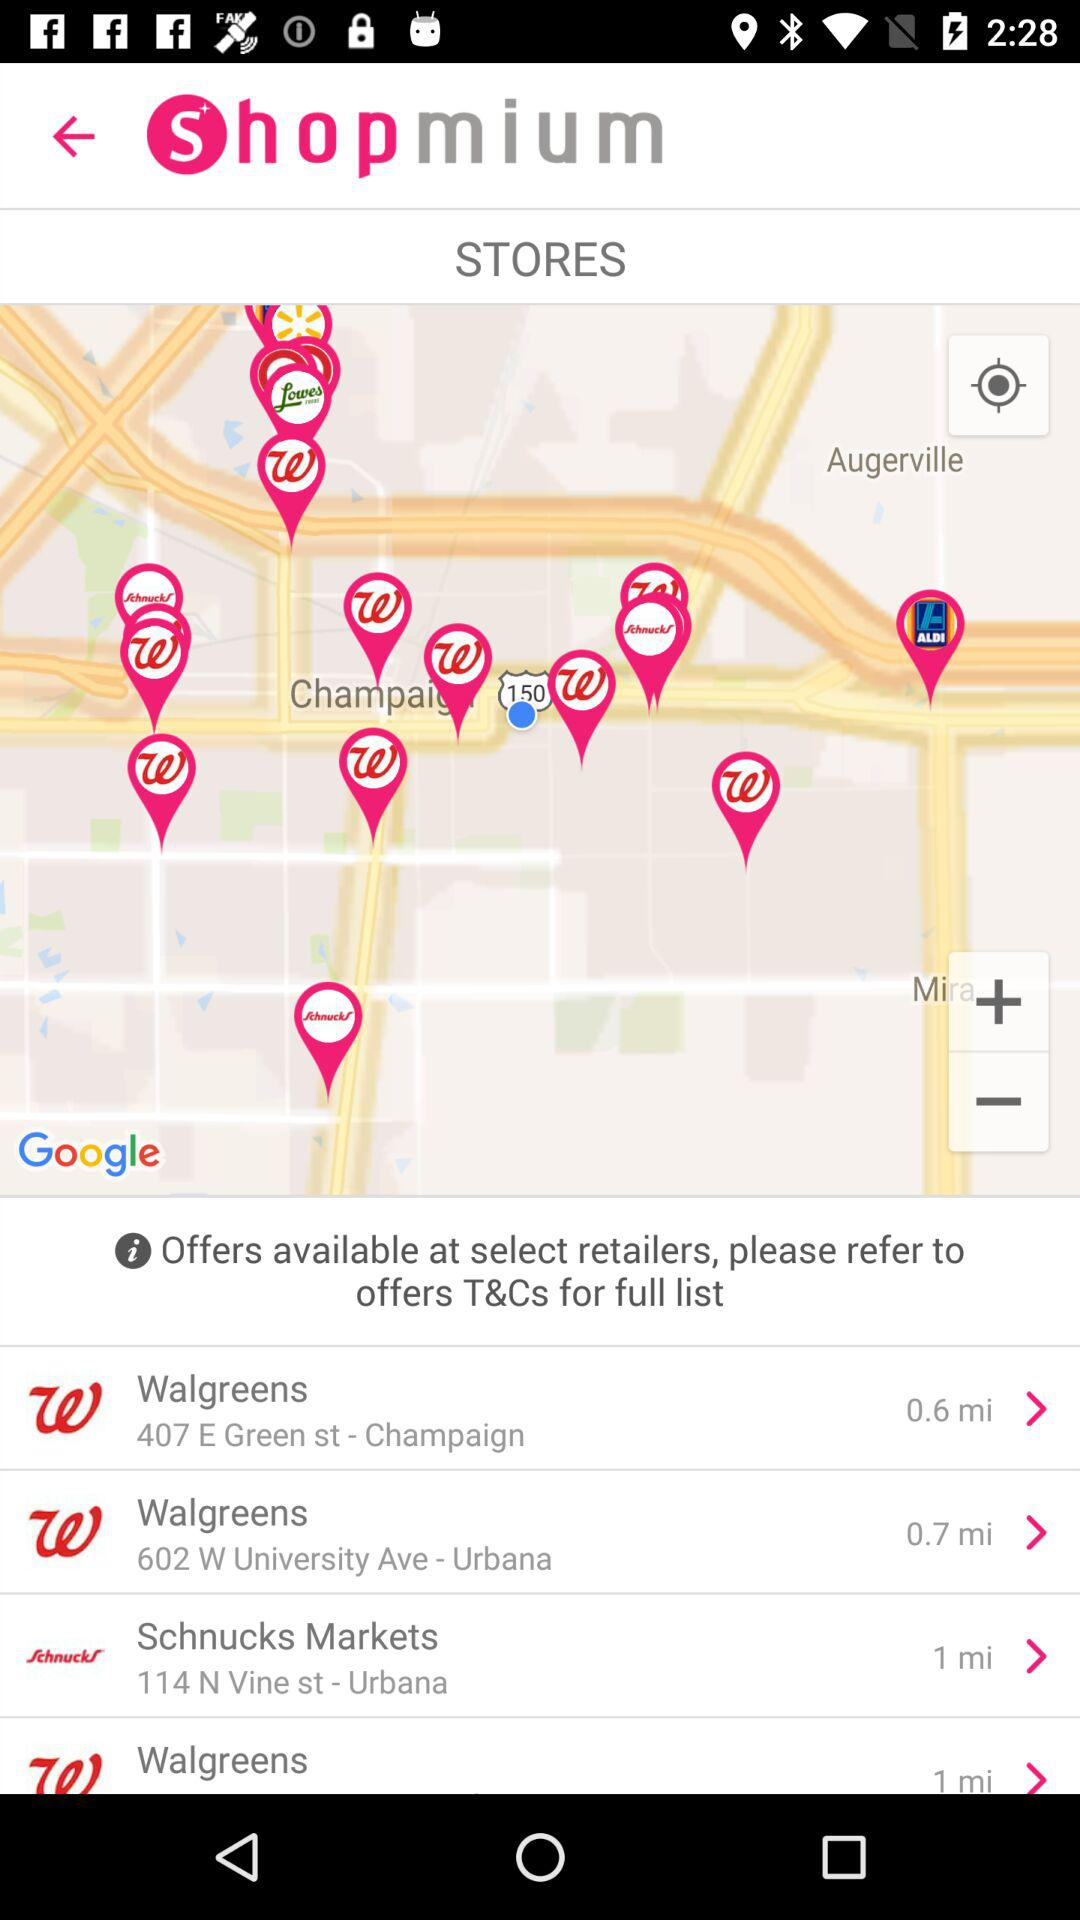What are the available stores? The available stores are "Walgreens" and "Schnucks Markets". 